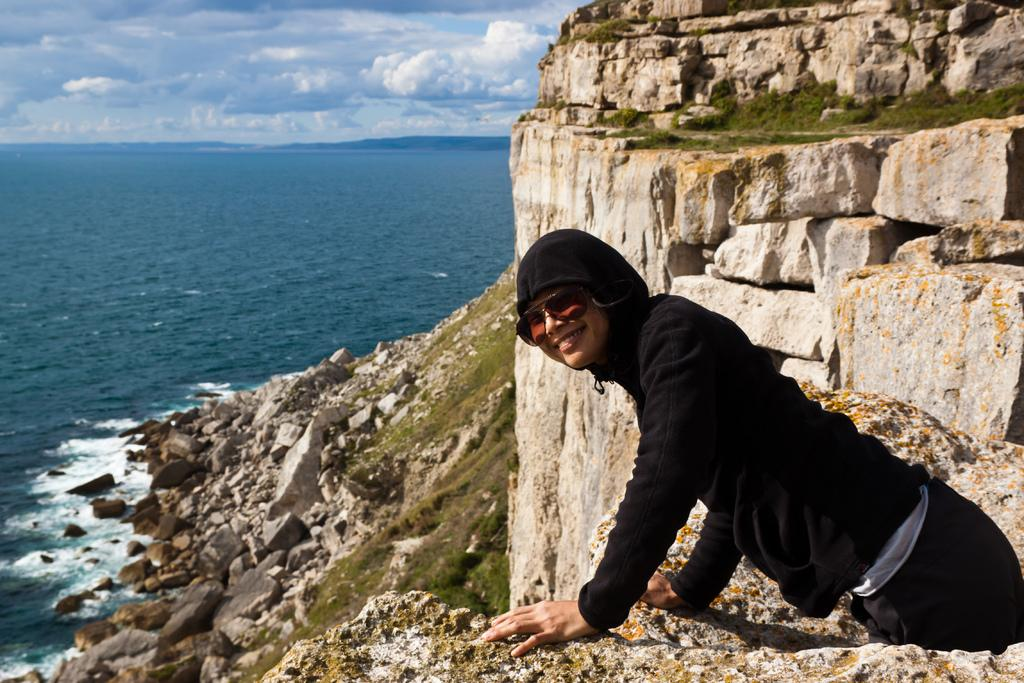What can be seen on the right side of the image? There is a person standing on the right side of the image. What is located on the left side of the image? There is a river on the left side of the image. What is visible in the background of the image? There is a sky visible in the background of the image. How many mice are playing with the wire in the image? There are no mice or wire present in the image. Are the children playing near the river in the image? There is no mention of children in the image; only a person and a river are present. 